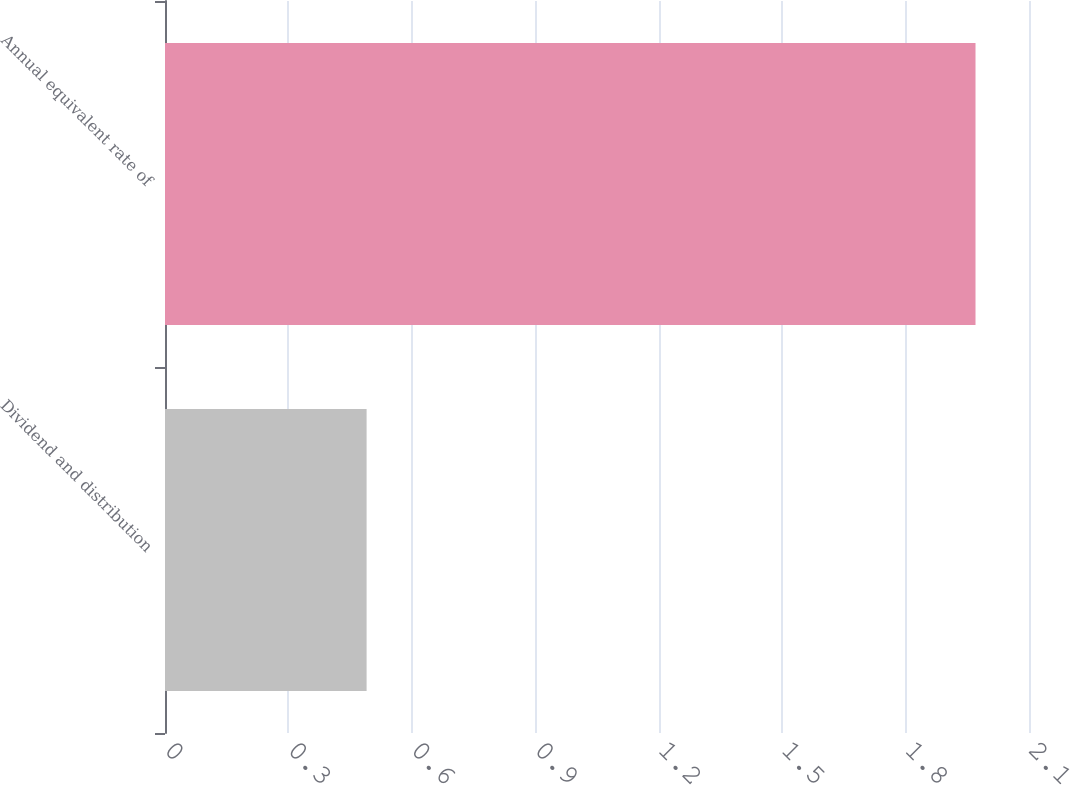<chart> <loc_0><loc_0><loc_500><loc_500><bar_chart><fcel>Dividend and distribution<fcel>Annual equivalent rate of<nl><fcel>0.49<fcel>1.97<nl></chart> 